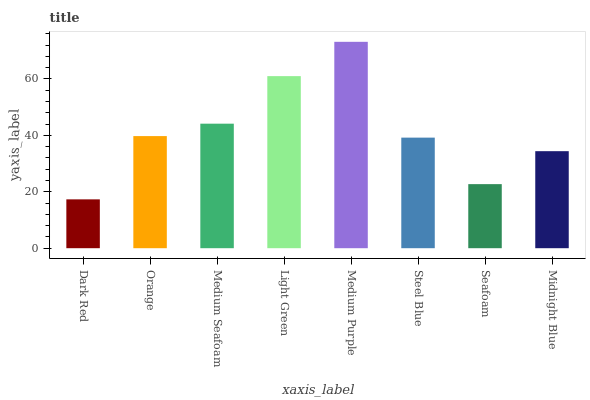Is Orange the minimum?
Answer yes or no. No. Is Orange the maximum?
Answer yes or no. No. Is Orange greater than Dark Red?
Answer yes or no. Yes. Is Dark Red less than Orange?
Answer yes or no. Yes. Is Dark Red greater than Orange?
Answer yes or no. No. Is Orange less than Dark Red?
Answer yes or no. No. Is Orange the high median?
Answer yes or no. Yes. Is Steel Blue the low median?
Answer yes or no. Yes. Is Medium Seafoam the high median?
Answer yes or no. No. Is Midnight Blue the low median?
Answer yes or no. No. 